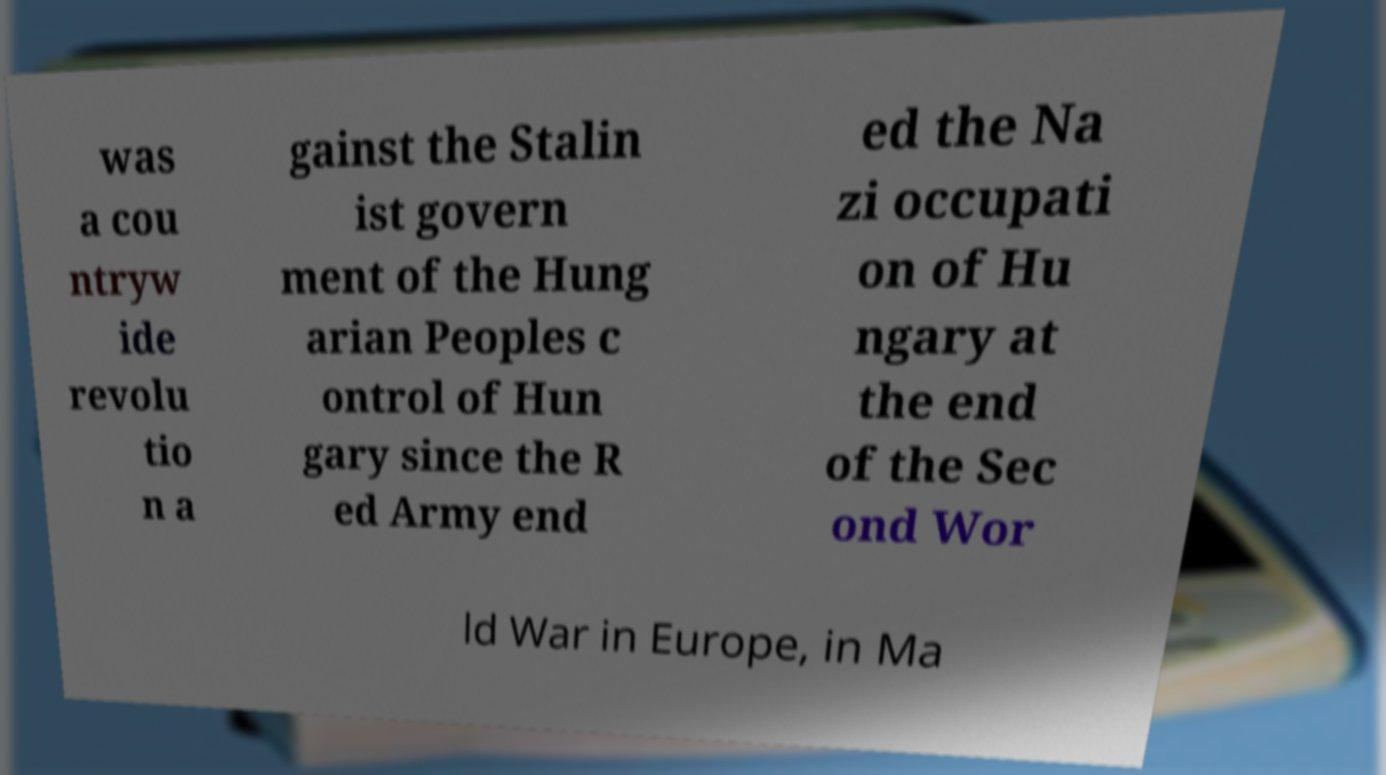Could you extract and type out the text from this image? was a cou ntryw ide revolu tio n a gainst the Stalin ist govern ment of the Hung arian Peoples c ontrol of Hun gary since the R ed Army end ed the Na zi occupati on of Hu ngary at the end of the Sec ond Wor ld War in Europe, in Ma 